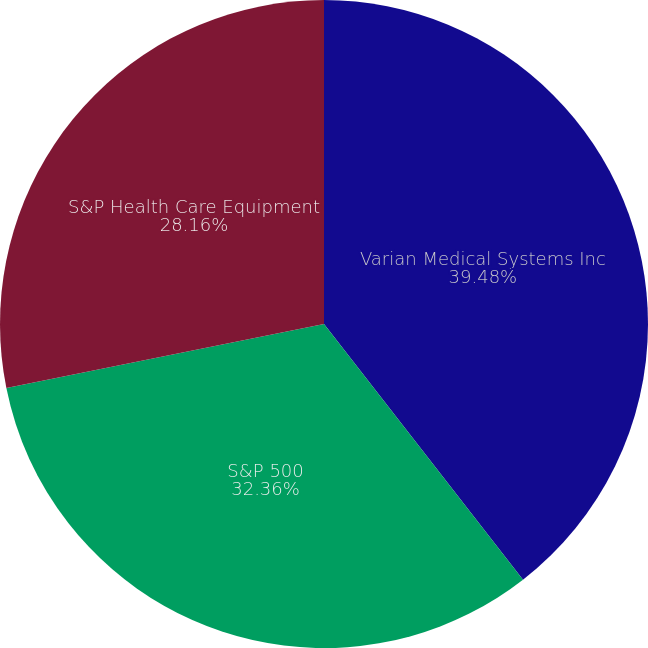Convert chart. <chart><loc_0><loc_0><loc_500><loc_500><pie_chart><fcel>Varian Medical Systems Inc<fcel>S&P 500<fcel>S&P Health Care Equipment<nl><fcel>39.47%<fcel>32.36%<fcel>28.16%<nl></chart> 